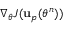<formula> <loc_0><loc_0><loc_500><loc_500>\nabla _ { \theta } J ( u _ { p } ( \theta ^ { n } ) )</formula> 